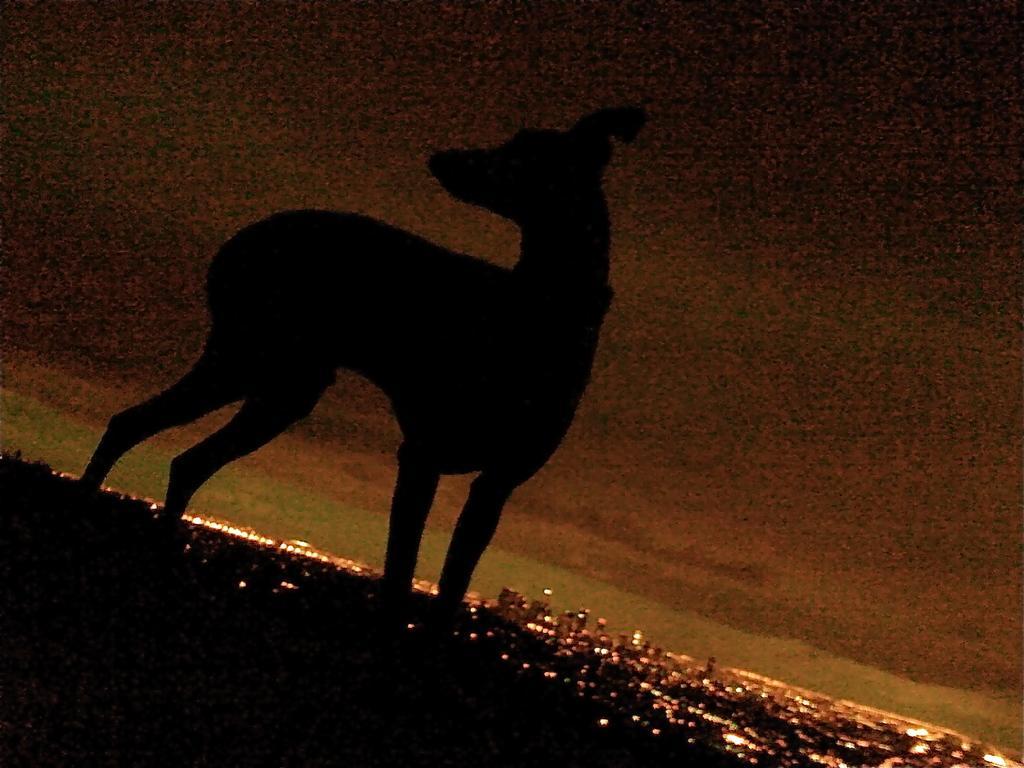In one or two sentences, can you explain what this image depicts? This image is taken outdoors. At the top of the image there is a sky with clouds. At the bottom of the image there are a few buildings and there are many lights. In the middle of the image there is an animal on the ground. 